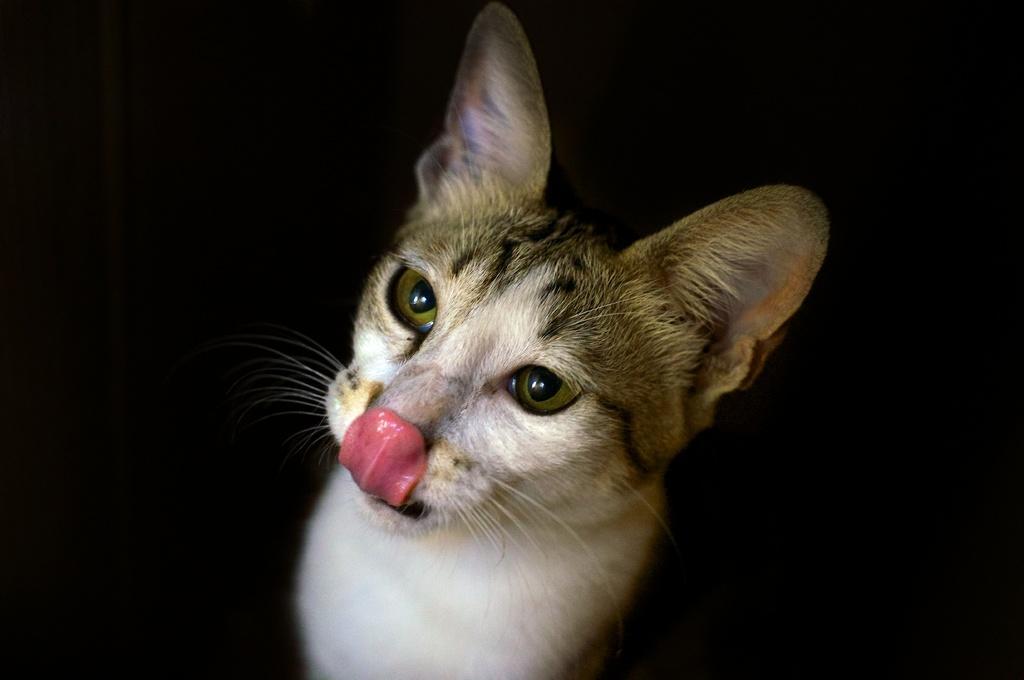Describe this image in one or two sentences. In this image there is one cat in middle of this image and the background of this image is in black color. 